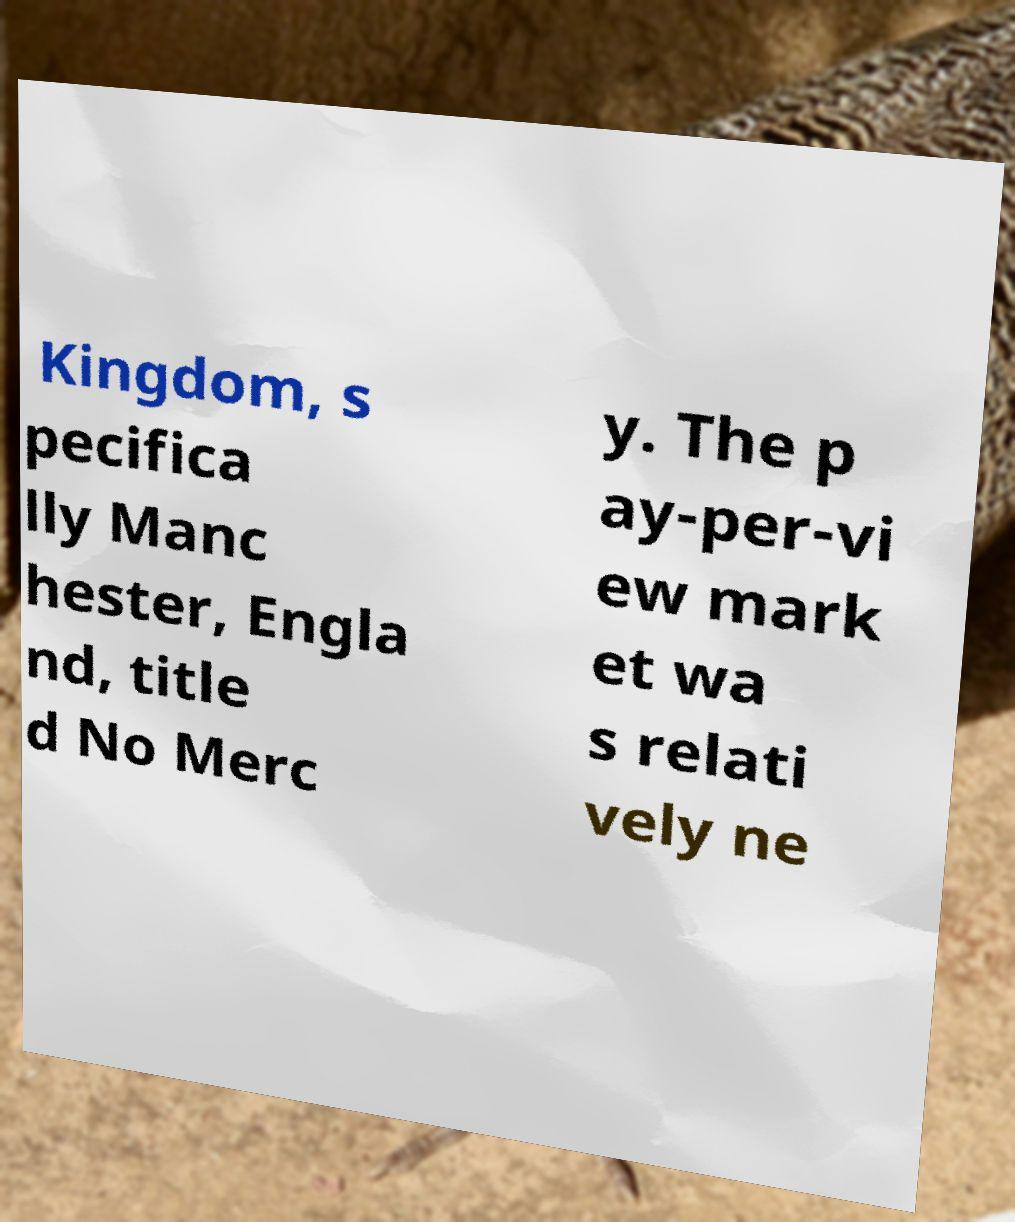What messages or text are displayed in this image? I need them in a readable, typed format. Kingdom, s pecifica lly Manc hester, Engla nd, title d No Merc y. The p ay-per-vi ew mark et wa s relati vely ne 